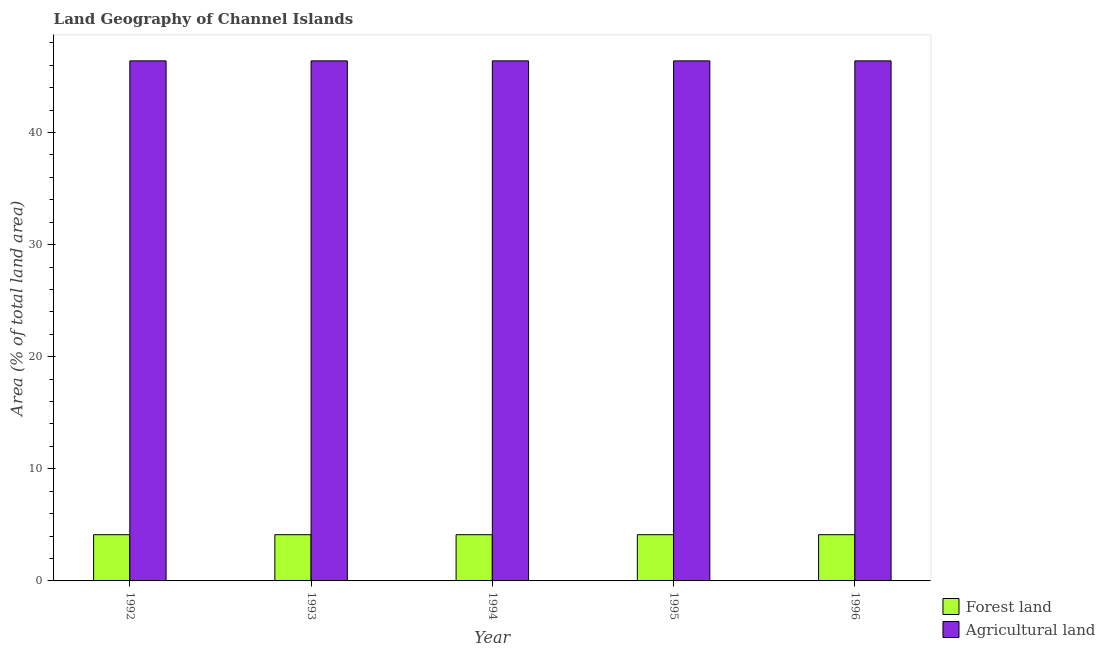Are the number of bars per tick equal to the number of legend labels?
Your response must be concise. Yes. Are the number of bars on each tick of the X-axis equal?
Provide a short and direct response. Yes. How many bars are there on the 3rd tick from the right?
Provide a short and direct response. 2. What is the percentage of land area under forests in 1996?
Make the answer very short. 4.12. Across all years, what is the maximum percentage of land area under agriculture?
Your answer should be compact. 46.39. Across all years, what is the minimum percentage of land area under forests?
Provide a succinct answer. 4.12. In which year was the percentage of land area under forests maximum?
Provide a short and direct response. 1992. What is the total percentage of land area under agriculture in the graph?
Make the answer very short. 231.96. What is the difference between the percentage of land area under agriculture in 1993 and that in 1996?
Offer a very short reply. 0. What is the average percentage of land area under forests per year?
Your response must be concise. 4.12. In the year 1994, what is the difference between the percentage of land area under forests and percentage of land area under agriculture?
Offer a terse response. 0. In how many years, is the percentage of land area under forests greater than 18 %?
Your answer should be very brief. 0. What is the ratio of the percentage of land area under forests in 1992 to that in 1993?
Offer a terse response. 1. What is the difference between the highest and the second highest percentage of land area under agriculture?
Offer a very short reply. 0. What is the difference between the highest and the lowest percentage of land area under agriculture?
Make the answer very short. 0. In how many years, is the percentage of land area under agriculture greater than the average percentage of land area under agriculture taken over all years?
Offer a very short reply. 0. What does the 2nd bar from the left in 1995 represents?
Provide a short and direct response. Agricultural land. What does the 2nd bar from the right in 1994 represents?
Your response must be concise. Forest land. How many years are there in the graph?
Ensure brevity in your answer.  5. What is the difference between two consecutive major ticks on the Y-axis?
Keep it short and to the point. 10. Does the graph contain grids?
Offer a terse response. No. Where does the legend appear in the graph?
Provide a short and direct response. Bottom right. How are the legend labels stacked?
Provide a succinct answer. Vertical. What is the title of the graph?
Keep it short and to the point. Land Geography of Channel Islands. Does "Mobile cellular" appear as one of the legend labels in the graph?
Ensure brevity in your answer.  No. What is the label or title of the Y-axis?
Provide a succinct answer. Area (% of total land area). What is the Area (% of total land area) in Forest land in 1992?
Your answer should be compact. 4.12. What is the Area (% of total land area) of Agricultural land in 1992?
Your answer should be very brief. 46.39. What is the Area (% of total land area) in Forest land in 1993?
Offer a terse response. 4.12. What is the Area (% of total land area) in Agricultural land in 1993?
Offer a very short reply. 46.39. What is the Area (% of total land area) of Forest land in 1994?
Give a very brief answer. 4.12. What is the Area (% of total land area) of Agricultural land in 1994?
Offer a very short reply. 46.39. What is the Area (% of total land area) of Forest land in 1995?
Provide a succinct answer. 4.12. What is the Area (% of total land area) of Agricultural land in 1995?
Offer a very short reply. 46.39. What is the Area (% of total land area) in Forest land in 1996?
Provide a short and direct response. 4.12. What is the Area (% of total land area) of Agricultural land in 1996?
Make the answer very short. 46.39. Across all years, what is the maximum Area (% of total land area) of Forest land?
Your answer should be very brief. 4.12. Across all years, what is the maximum Area (% of total land area) in Agricultural land?
Offer a very short reply. 46.39. Across all years, what is the minimum Area (% of total land area) in Forest land?
Provide a short and direct response. 4.12. Across all years, what is the minimum Area (% of total land area) in Agricultural land?
Your response must be concise. 46.39. What is the total Area (% of total land area) in Forest land in the graph?
Your answer should be very brief. 20.62. What is the total Area (% of total land area) of Agricultural land in the graph?
Provide a succinct answer. 231.96. What is the difference between the Area (% of total land area) of Forest land in 1992 and that in 1993?
Offer a terse response. 0. What is the difference between the Area (% of total land area) in Forest land in 1992 and that in 1994?
Make the answer very short. 0. What is the difference between the Area (% of total land area) of Forest land in 1992 and that in 1995?
Make the answer very short. 0. What is the difference between the Area (% of total land area) of Forest land in 1993 and that in 1994?
Make the answer very short. 0. What is the difference between the Area (% of total land area) of Agricultural land in 1993 and that in 1994?
Ensure brevity in your answer.  0. What is the difference between the Area (% of total land area) in Agricultural land in 1993 and that in 1995?
Give a very brief answer. 0. What is the difference between the Area (% of total land area) of Forest land in 1993 and that in 1996?
Offer a terse response. 0. What is the difference between the Area (% of total land area) of Agricultural land in 1994 and that in 1996?
Make the answer very short. 0. What is the difference between the Area (% of total land area) in Forest land in 1995 and that in 1996?
Provide a succinct answer. 0. What is the difference between the Area (% of total land area) in Agricultural land in 1995 and that in 1996?
Your answer should be compact. 0. What is the difference between the Area (% of total land area) in Forest land in 1992 and the Area (% of total land area) in Agricultural land in 1993?
Provide a short and direct response. -42.27. What is the difference between the Area (% of total land area) of Forest land in 1992 and the Area (% of total land area) of Agricultural land in 1994?
Your response must be concise. -42.27. What is the difference between the Area (% of total land area) in Forest land in 1992 and the Area (% of total land area) in Agricultural land in 1995?
Keep it short and to the point. -42.27. What is the difference between the Area (% of total land area) in Forest land in 1992 and the Area (% of total land area) in Agricultural land in 1996?
Ensure brevity in your answer.  -42.27. What is the difference between the Area (% of total land area) in Forest land in 1993 and the Area (% of total land area) in Agricultural land in 1994?
Keep it short and to the point. -42.27. What is the difference between the Area (% of total land area) of Forest land in 1993 and the Area (% of total land area) of Agricultural land in 1995?
Offer a very short reply. -42.27. What is the difference between the Area (% of total land area) in Forest land in 1993 and the Area (% of total land area) in Agricultural land in 1996?
Give a very brief answer. -42.27. What is the difference between the Area (% of total land area) in Forest land in 1994 and the Area (% of total land area) in Agricultural land in 1995?
Make the answer very short. -42.27. What is the difference between the Area (% of total land area) of Forest land in 1994 and the Area (% of total land area) of Agricultural land in 1996?
Ensure brevity in your answer.  -42.27. What is the difference between the Area (% of total land area) in Forest land in 1995 and the Area (% of total land area) in Agricultural land in 1996?
Ensure brevity in your answer.  -42.27. What is the average Area (% of total land area) of Forest land per year?
Offer a terse response. 4.12. What is the average Area (% of total land area) of Agricultural land per year?
Provide a succinct answer. 46.39. In the year 1992, what is the difference between the Area (% of total land area) of Forest land and Area (% of total land area) of Agricultural land?
Offer a very short reply. -42.27. In the year 1993, what is the difference between the Area (% of total land area) of Forest land and Area (% of total land area) of Agricultural land?
Give a very brief answer. -42.27. In the year 1994, what is the difference between the Area (% of total land area) of Forest land and Area (% of total land area) of Agricultural land?
Provide a short and direct response. -42.27. In the year 1995, what is the difference between the Area (% of total land area) of Forest land and Area (% of total land area) of Agricultural land?
Your answer should be compact. -42.27. In the year 1996, what is the difference between the Area (% of total land area) in Forest land and Area (% of total land area) in Agricultural land?
Offer a very short reply. -42.27. What is the ratio of the Area (% of total land area) of Forest land in 1992 to that in 1994?
Provide a succinct answer. 1. What is the ratio of the Area (% of total land area) in Forest land in 1992 to that in 1995?
Give a very brief answer. 1. What is the ratio of the Area (% of total land area) in Agricultural land in 1992 to that in 1995?
Provide a short and direct response. 1. What is the ratio of the Area (% of total land area) in Forest land in 1992 to that in 1996?
Give a very brief answer. 1. What is the ratio of the Area (% of total land area) in Agricultural land in 1992 to that in 1996?
Keep it short and to the point. 1. What is the ratio of the Area (% of total land area) in Forest land in 1993 to that in 1994?
Make the answer very short. 1. What is the ratio of the Area (% of total land area) in Agricultural land in 1993 to that in 1994?
Provide a short and direct response. 1. What is the ratio of the Area (% of total land area) of Agricultural land in 1993 to that in 1995?
Offer a very short reply. 1. What is the ratio of the Area (% of total land area) in Forest land in 1993 to that in 1996?
Provide a succinct answer. 1. What is the ratio of the Area (% of total land area) of Agricultural land in 1993 to that in 1996?
Your answer should be compact. 1. What is the ratio of the Area (% of total land area) in Agricultural land in 1994 to that in 1995?
Offer a very short reply. 1. What is the ratio of the Area (% of total land area) of Forest land in 1994 to that in 1996?
Ensure brevity in your answer.  1. What is the ratio of the Area (% of total land area) of Forest land in 1995 to that in 1996?
Your response must be concise. 1. What is the difference between the highest and the second highest Area (% of total land area) of Agricultural land?
Make the answer very short. 0. What is the difference between the highest and the lowest Area (% of total land area) of Agricultural land?
Provide a succinct answer. 0. 